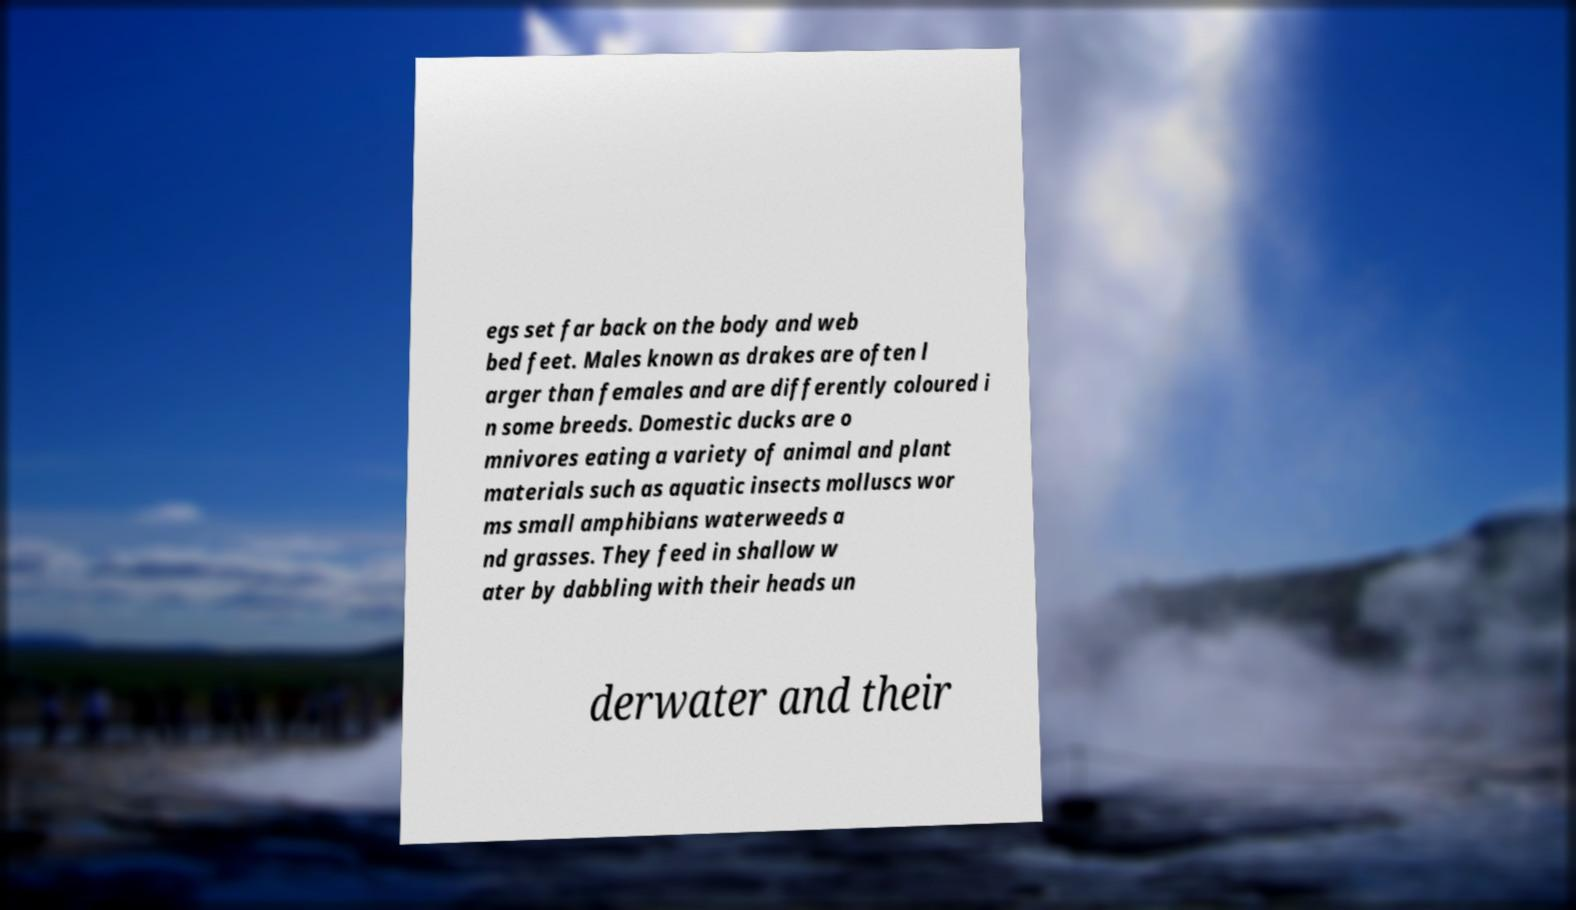What messages or text are displayed in this image? I need them in a readable, typed format. egs set far back on the body and web bed feet. Males known as drakes are often l arger than females and are differently coloured i n some breeds. Domestic ducks are o mnivores eating a variety of animal and plant materials such as aquatic insects molluscs wor ms small amphibians waterweeds a nd grasses. They feed in shallow w ater by dabbling with their heads un derwater and their 